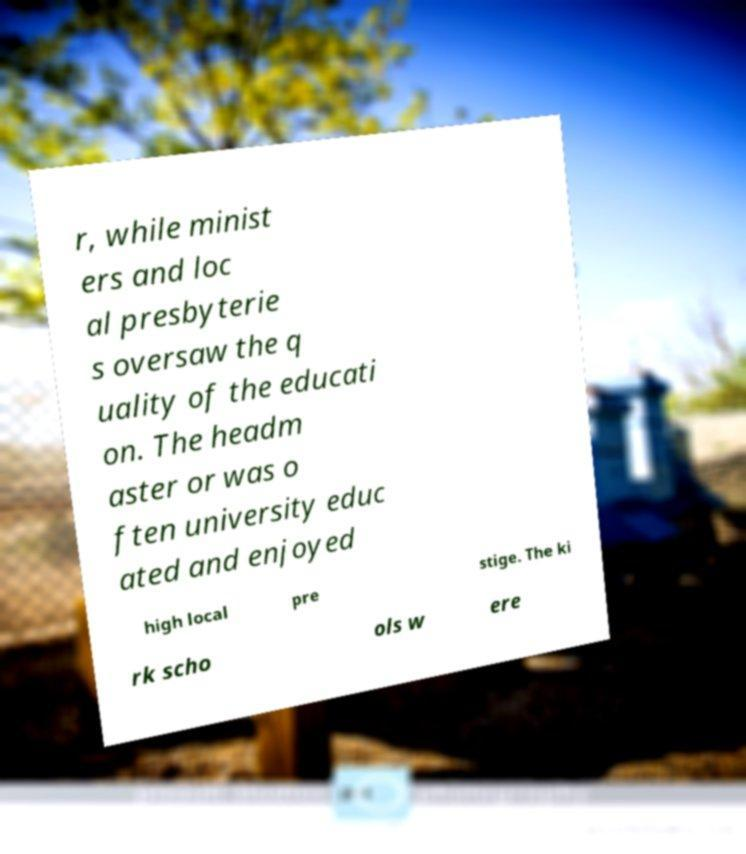What messages or text are displayed in this image? I need them in a readable, typed format. r, while minist ers and loc al presbyterie s oversaw the q uality of the educati on. The headm aster or was o ften university educ ated and enjoyed high local pre stige. The ki rk scho ols w ere 